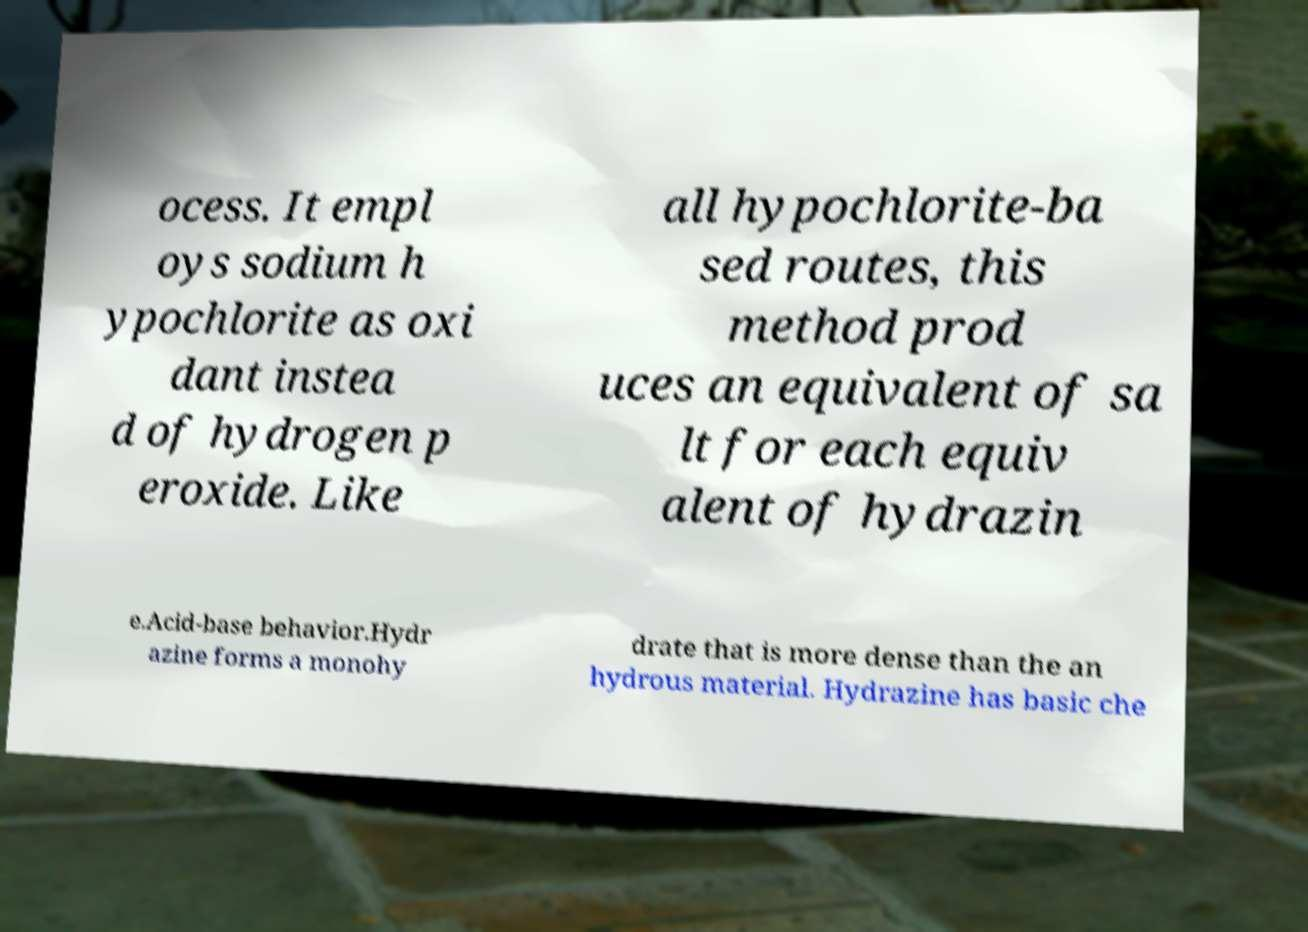Please read and relay the text visible in this image. What does it say? ocess. It empl oys sodium h ypochlorite as oxi dant instea d of hydrogen p eroxide. Like all hypochlorite-ba sed routes, this method prod uces an equivalent of sa lt for each equiv alent of hydrazin e.Acid-base behavior.Hydr azine forms a monohy drate that is more dense than the an hydrous material. Hydrazine has basic che 